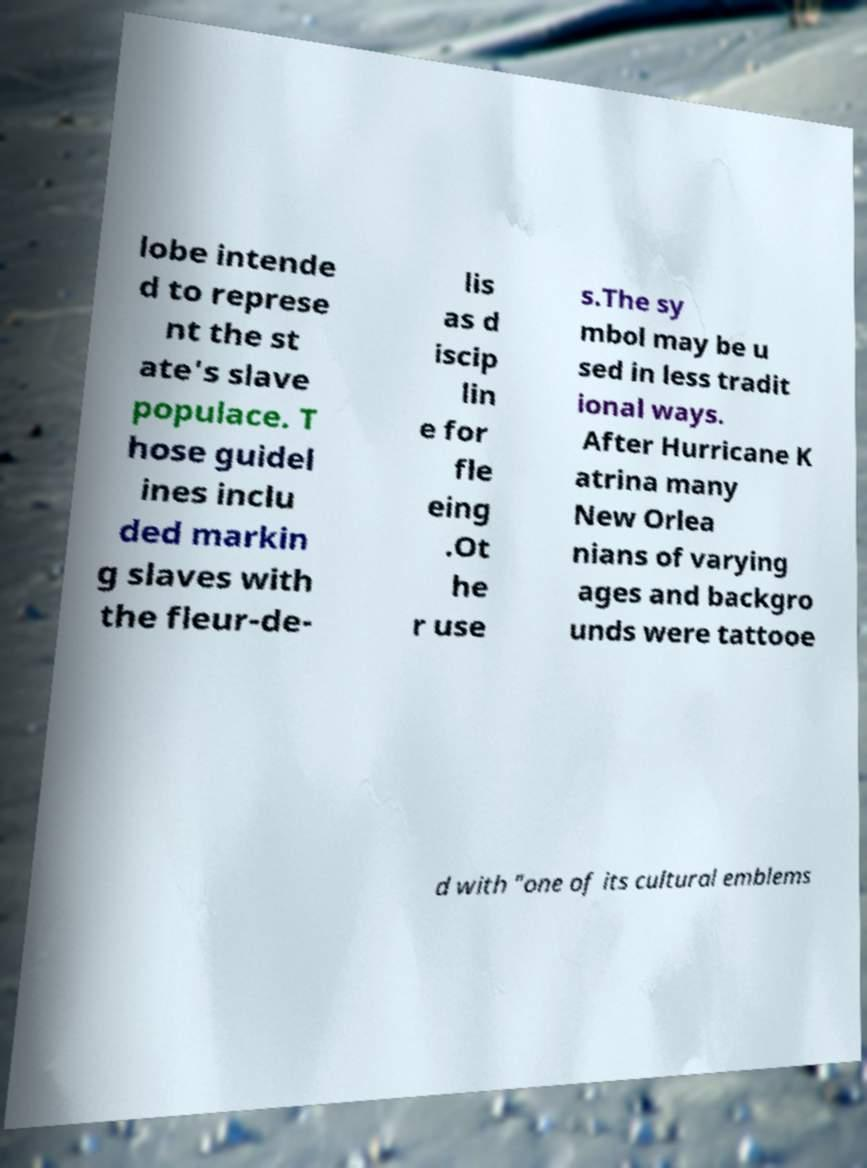Can you read and provide the text displayed in the image?This photo seems to have some interesting text. Can you extract and type it out for me? lobe intende d to represe nt the st ate's slave populace. T hose guidel ines inclu ded markin g slaves with the fleur-de- lis as d iscip lin e for fle eing .Ot he r use s.The sy mbol may be u sed in less tradit ional ways. After Hurricane K atrina many New Orlea nians of varying ages and backgro unds were tattooe d with "one of its cultural emblems 